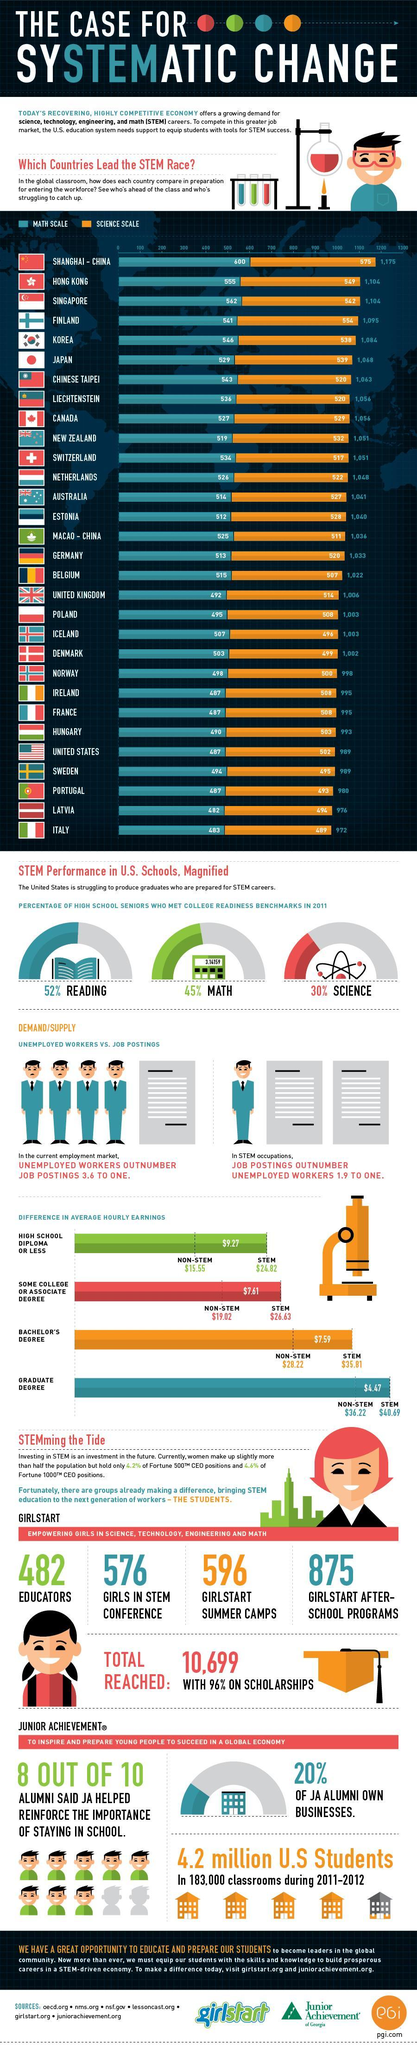How many countries have total scale less than 1000 in Math and Science?
Answer the question with a short phrase. 9 What percentage of high school seniors do not meet the college readiness for Science? 70% Which countries have  total scale of 989 in Math and Science? United States, Sweden How many countries have a scale less than 500 in Math? 11 What is the number of girl after school programs for STEM 576, 596, or 875? 875 How many countries have a scale lees than 500 in Science? 6 Which country has scale of 546 in Math and a scale of 538 in Science? Korea Which countries have a scale of 995 in Science and 487 in Math? Ireland, France 